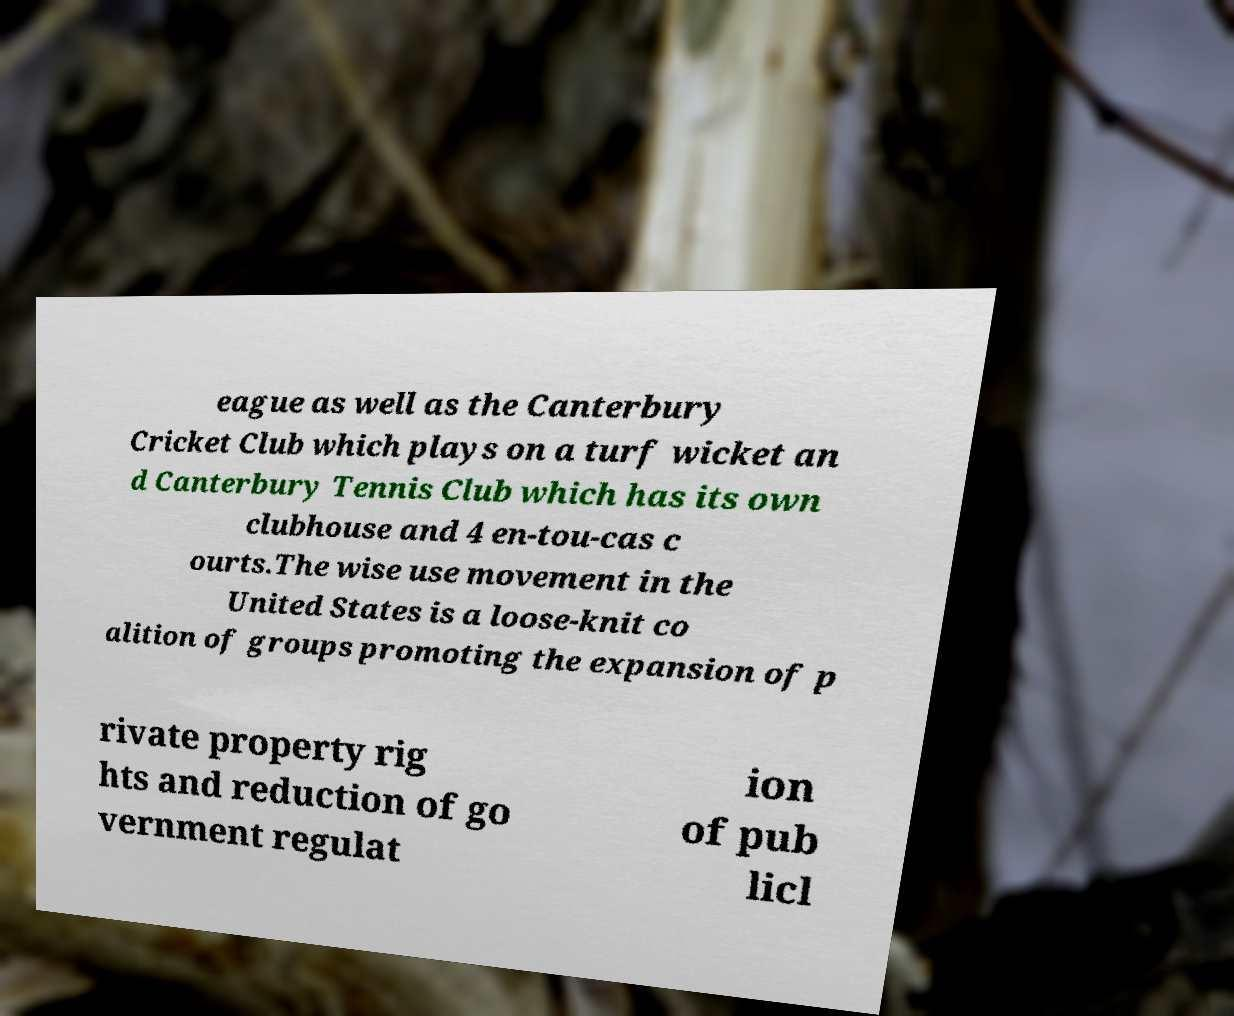There's text embedded in this image that I need extracted. Can you transcribe it verbatim? eague as well as the Canterbury Cricket Club which plays on a turf wicket an d Canterbury Tennis Club which has its own clubhouse and 4 en-tou-cas c ourts.The wise use movement in the United States is a loose-knit co alition of groups promoting the expansion of p rivate property rig hts and reduction of go vernment regulat ion of pub licl 